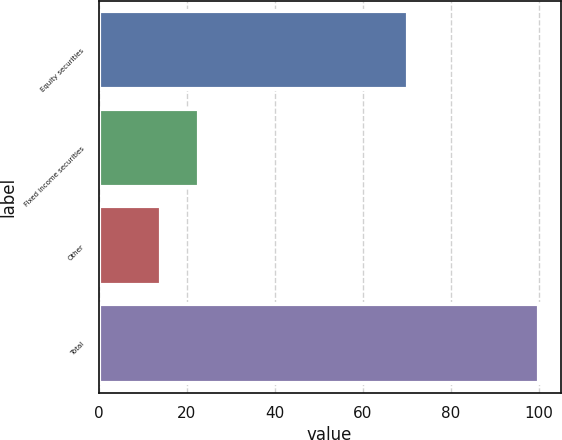<chart> <loc_0><loc_0><loc_500><loc_500><bar_chart><fcel>Equity securities<fcel>Fixed income securities<fcel>Other<fcel>Total<nl><fcel>70.4<fcel>22.69<fcel>14.1<fcel>100<nl></chart> 